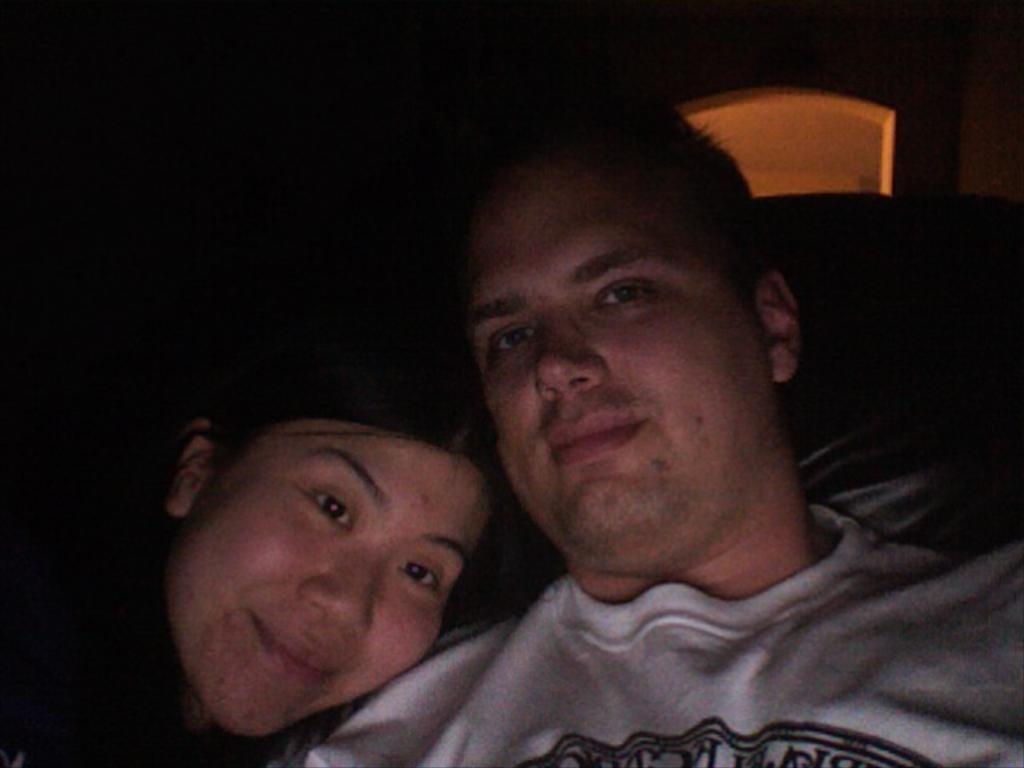How many people are in the image? There are two people in the image. Can you describe the gender of the people? One of the people is a man, and the other person is a woman. What can be observed about the background of the image? The background of the image is dark. What type of glass is being used by the man in the image? There is no glass present in the image. 